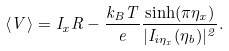Convert formula to latex. <formula><loc_0><loc_0><loc_500><loc_500>\langle V \rangle = I _ { x } R - \frac { k _ { B } T } { e } \frac { \sinh ( \pi \eta _ { x } ) } { | I _ { i \eta _ { x } } ( \eta _ { b } ) | ^ { 2 } } .</formula> 